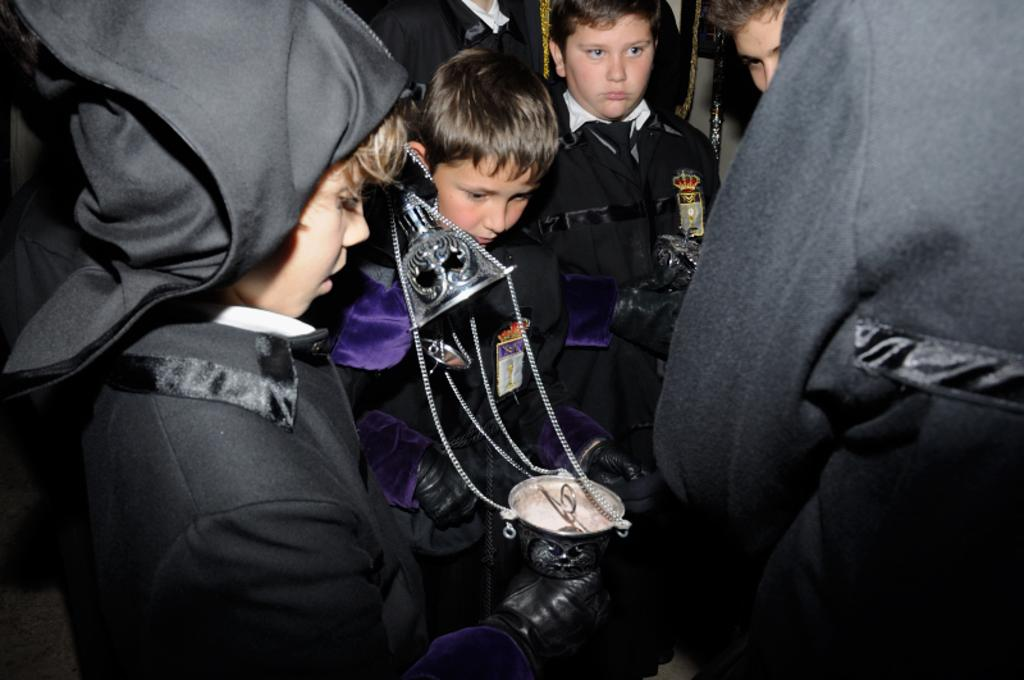How many people are in the image? There are people in the image, but the exact number is not specified. What are some of the people doing in the image? Some of the people are standing in the image. Can you describe any actions or interactions involving the people? One person is holding an object in their hand. What type of fang can be seen in the image? There is no fang present in the image. What kind of machine is being operated by the people in the image? The facts provided do not mention any machines or their operation. 